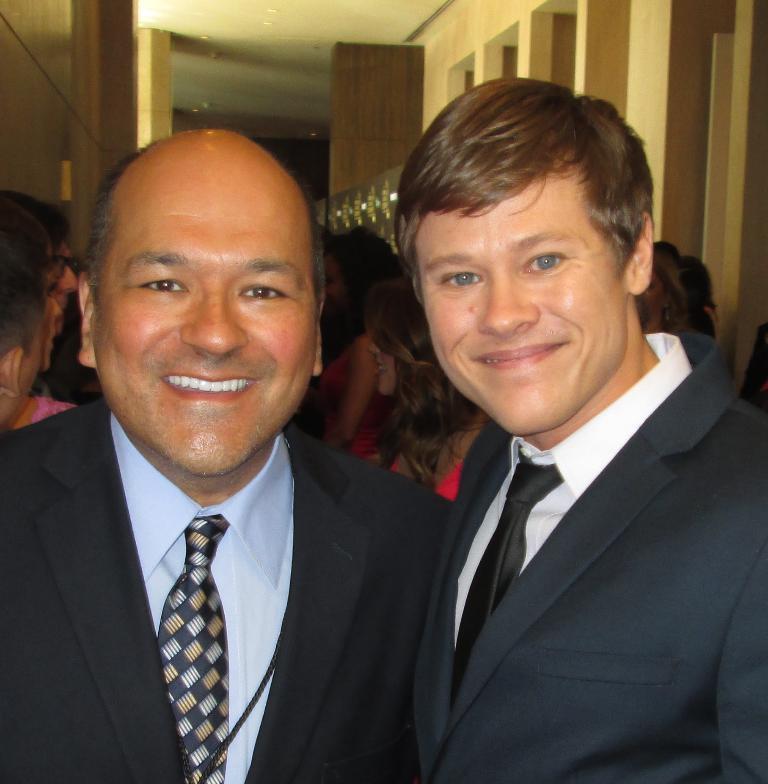Describe this image in one or two sentences. In the foreground of this picture we can see the two persons wearing suits and smiling. In the center we can see the group of persons seems to be standing. In the background we can see the roof, ceiling lights, pillars and some other objects. 